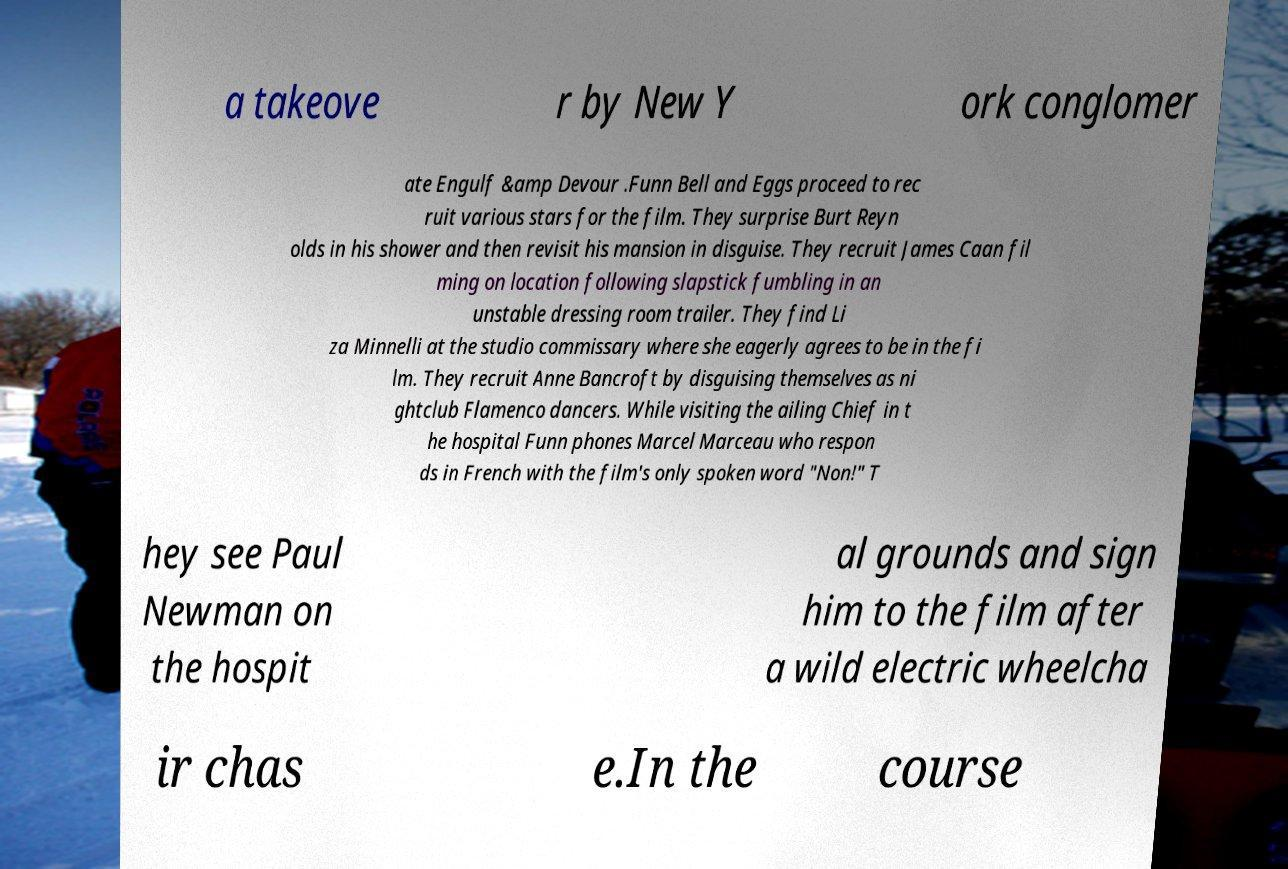What messages or text are displayed in this image? I need them in a readable, typed format. a takeove r by New Y ork conglomer ate Engulf &amp Devour .Funn Bell and Eggs proceed to rec ruit various stars for the film. They surprise Burt Reyn olds in his shower and then revisit his mansion in disguise. They recruit James Caan fil ming on location following slapstick fumbling in an unstable dressing room trailer. They find Li za Minnelli at the studio commissary where she eagerly agrees to be in the fi lm. They recruit Anne Bancroft by disguising themselves as ni ghtclub Flamenco dancers. While visiting the ailing Chief in t he hospital Funn phones Marcel Marceau who respon ds in French with the film's only spoken word "Non!" T hey see Paul Newman on the hospit al grounds and sign him to the film after a wild electric wheelcha ir chas e.In the course 